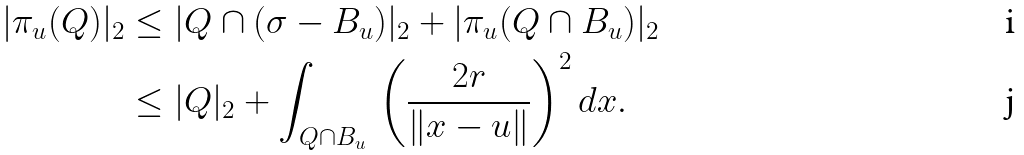<formula> <loc_0><loc_0><loc_500><loc_500>| \pi _ { u } ( Q ) | _ { 2 } & \leq | Q \cap ( \sigma - B _ { u } ) | _ { 2 } + | \pi _ { u } ( Q \cap B _ { u } ) | _ { 2 } \\ & \leq | Q | _ { 2 } + \int _ { Q \cap B _ { u } } \, { \left ( \frac { 2 r } { \| x - u \| } \right ) } ^ { 2 } \, d x .</formula> 